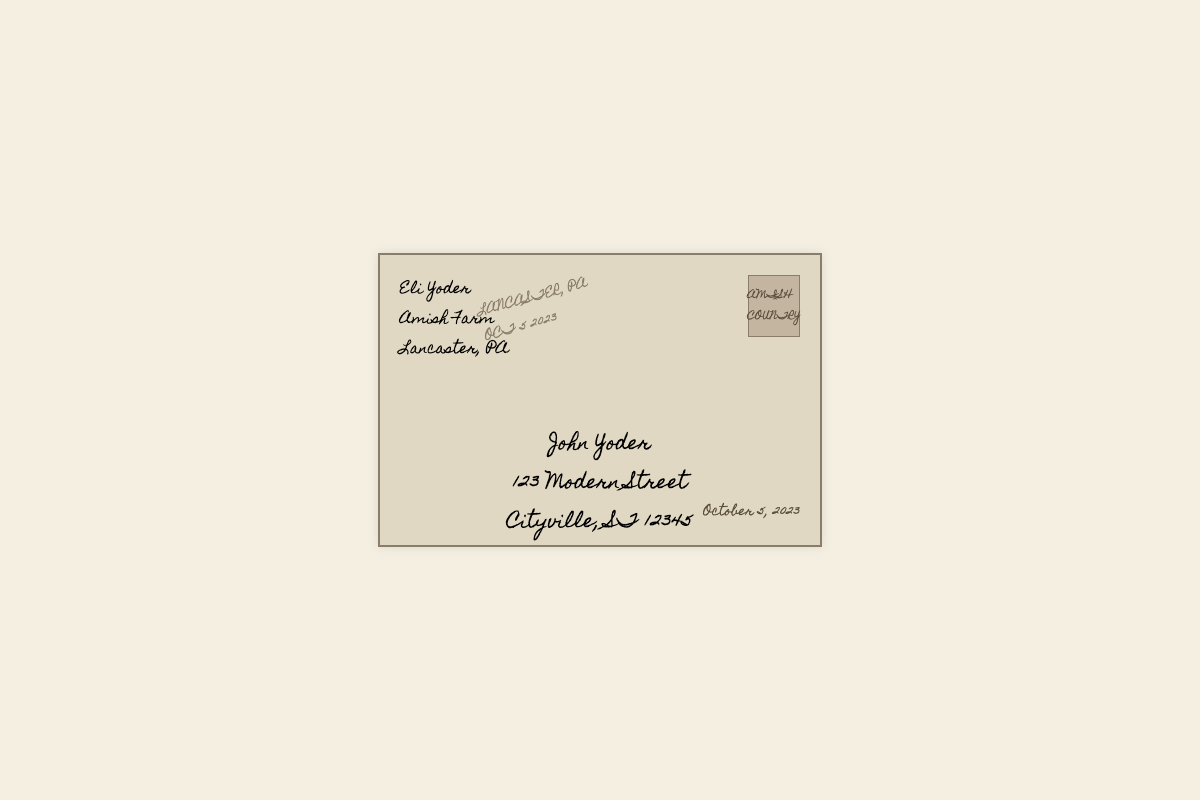What is the sender's name? The sender's name is found in the envelope and is listed at the top.
Answer: Eli Yoder What date was the letter sent? The date of sending is specified in the bottom right corner of the envelope.
Answer: October 5, 2023 What is the recipient's address? The recipient's address is located in the center of the envelope, right below the recipient's name.
Answer: 123 Modern Street, Cityville, ST 12345 What town is the sender from? The sender's location is mentioned just below their name on the envelope.
Answer: Lancaster What is the sender's occupation? The sender's occupation is indicated in the address section of the envelope.
Answer: Amish Farmer What is the purpose of the stamp on the envelope? The stamp signifies the place of origin for postal services, usually providing a location context.
Answer: AMISH COUNTRY Why is there a postmark on the envelope? The postmark indicates the location and date where the letter was mailed, as found on the envelope.
Answer: LANCASTER, PA, OCT 5 2023 What visual style is used for the text on the envelope? The envelope uses a specific cursive font style that is displayed prominently throughout.
Answer: Homemade Apple How does the envelope convey a traditional touch? The overall design elements suggest simplicity and rustic aesthetics typical of the sender's background.
Answer: Handwritten letter design 